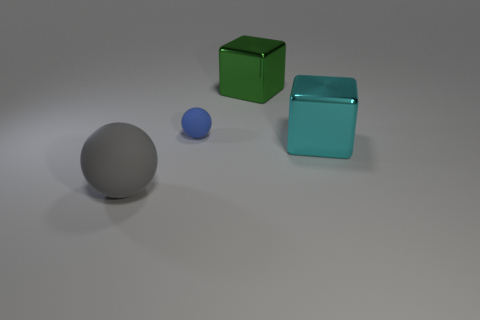Are any cyan metal things visible?
Offer a very short reply. Yes. The gray object that is the same material as the tiny blue thing is what shape?
Provide a short and direct response. Sphere. What is the big thing that is on the right side of the large green metallic cube made of?
Offer a very short reply. Metal. Does the rubber thing behind the cyan metal object have the same color as the big rubber thing?
Your response must be concise. No. There is a metal object left of the metallic cube right of the large green metallic cube; how big is it?
Offer a very short reply. Large. Are there more big green metallic cubes that are in front of the large cyan shiny block than cyan things?
Your response must be concise. No. There is a ball that is behind the gray ball; is its size the same as the big sphere?
Provide a short and direct response. No. There is a object that is both behind the cyan metal object and in front of the green metal thing; what color is it?
Ensure brevity in your answer.  Blue. There is a rubber object that is the same size as the cyan block; what shape is it?
Your response must be concise. Sphere. Are there any tiny objects that have the same color as the large matte ball?
Make the answer very short. No. 